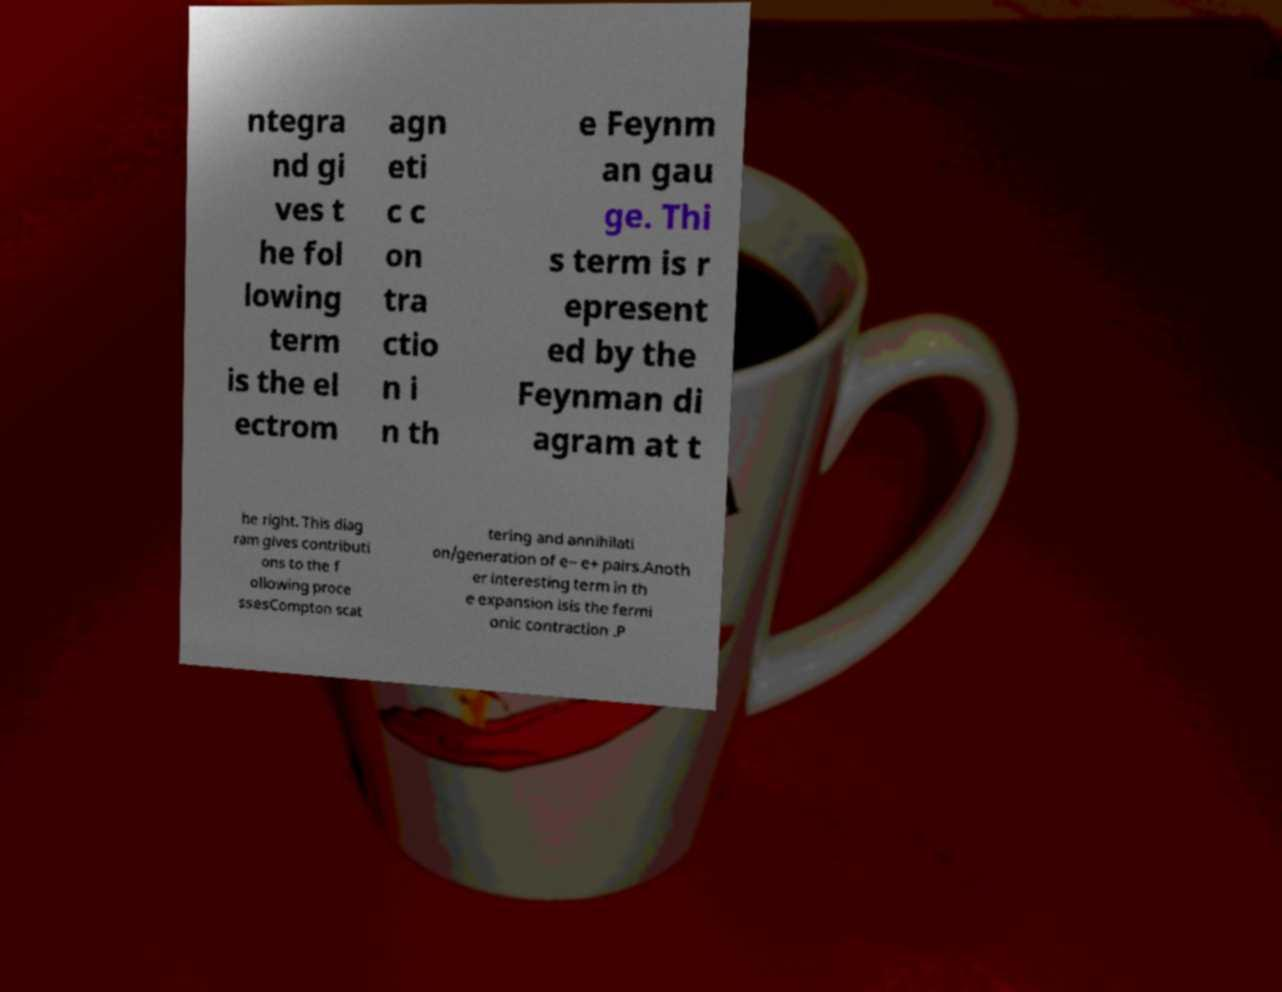Please read and relay the text visible in this image. What does it say? ntegra nd gi ves t he fol lowing term is the el ectrom agn eti c c on tra ctio n i n th e Feynm an gau ge. Thi s term is r epresent ed by the Feynman di agram at t he right. This diag ram gives contributi ons to the f ollowing proce ssesCompton scat tering and annihilati on/generation of e− e+ pairs.Anoth er interesting term in th e expansion isis the fermi onic contraction .P 